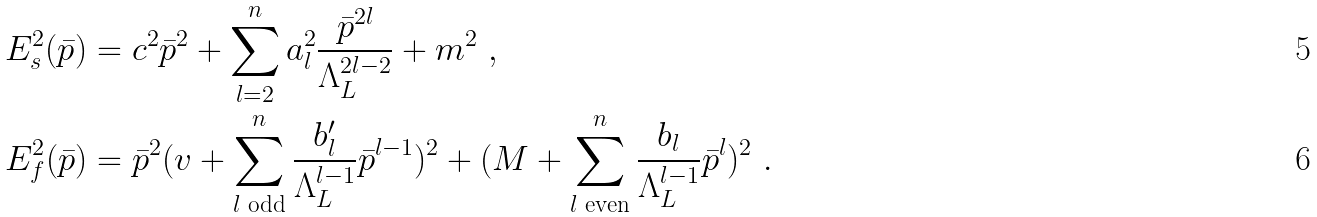<formula> <loc_0><loc_0><loc_500><loc_500>& E ^ { 2 } _ { s } ( \bar { p } ) = c ^ { 2 } \bar { p } ^ { 2 } + \sum _ { l = 2 } ^ { n } a ^ { 2 } _ { l } \frac { \bar { p } ^ { 2 l } } { \Lambda _ { L } ^ { 2 l - 2 } } + m ^ { 2 } \ , \\ & E ^ { 2 } _ { f } ( \bar { p } ) = \bar { p } ^ { 2 } ( v + \sum _ { l \text { odd} } ^ { n } \frac { b _ { l } ^ { \prime } } { \Lambda _ { L } ^ { l - 1 } } \bar { p } ^ { l - 1 } ) ^ { 2 } + ( M + \sum _ { l \text { even} } ^ { n } \frac { b _ { l } } { \Lambda _ { L } ^ { l - 1 } } \bar { p } ^ { l } ) ^ { 2 } \ .</formula> 